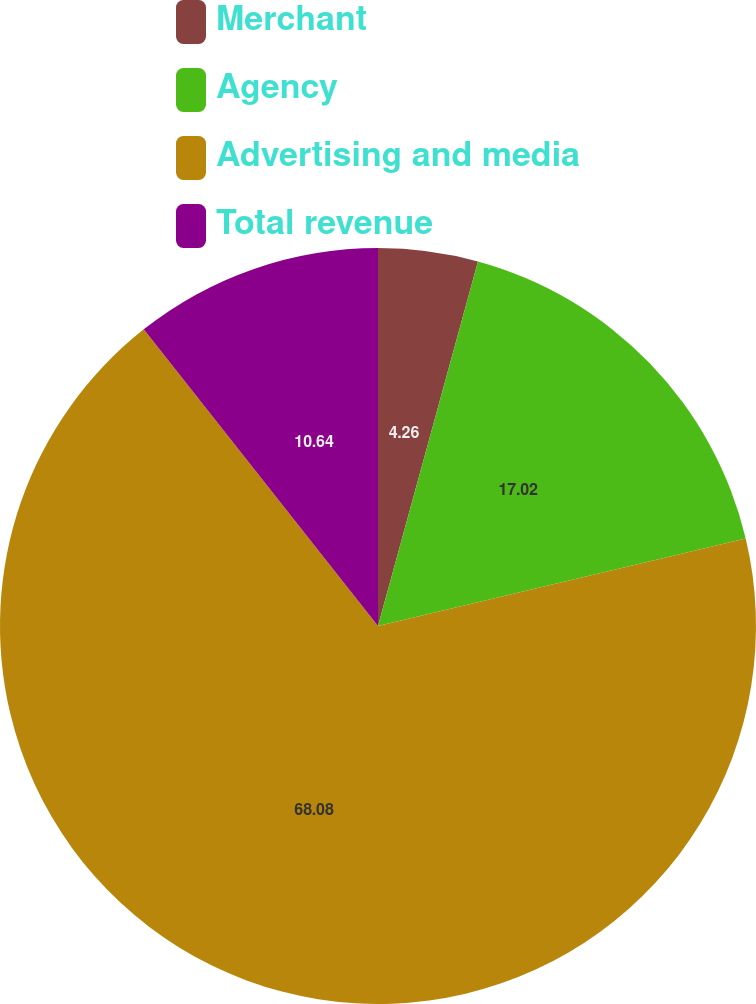<chart> <loc_0><loc_0><loc_500><loc_500><pie_chart><fcel>Merchant<fcel>Agency<fcel>Advertising and media<fcel>Total revenue<nl><fcel>4.26%<fcel>17.02%<fcel>68.09%<fcel>10.64%<nl></chart> 